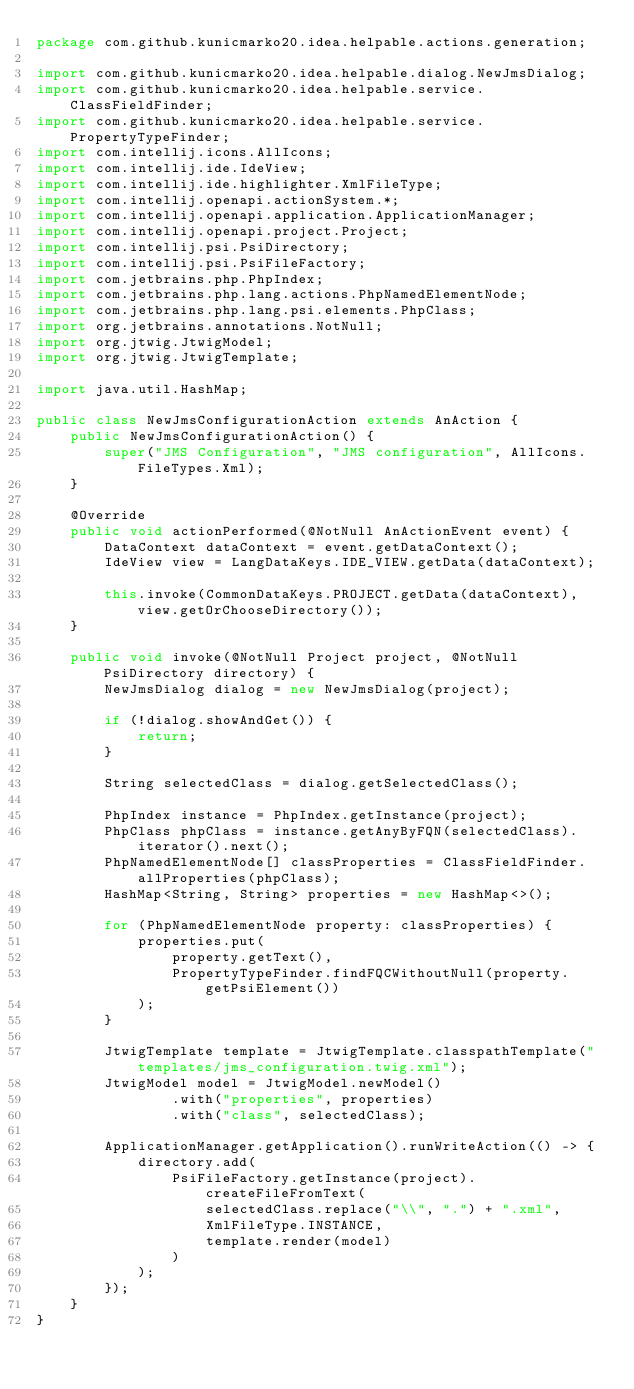<code> <loc_0><loc_0><loc_500><loc_500><_Java_>package com.github.kunicmarko20.idea.helpable.actions.generation;

import com.github.kunicmarko20.idea.helpable.dialog.NewJmsDialog;
import com.github.kunicmarko20.idea.helpable.service.ClassFieldFinder;
import com.github.kunicmarko20.idea.helpable.service.PropertyTypeFinder;
import com.intellij.icons.AllIcons;
import com.intellij.ide.IdeView;
import com.intellij.ide.highlighter.XmlFileType;
import com.intellij.openapi.actionSystem.*;
import com.intellij.openapi.application.ApplicationManager;
import com.intellij.openapi.project.Project;
import com.intellij.psi.PsiDirectory;
import com.intellij.psi.PsiFileFactory;
import com.jetbrains.php.PhpIndex;
import com.jetbrains.php.lang.actions.PhpNamedElementNode;
import com.jetbrains.php.lang.psi.elements.PhpClass;
import org.jetbrains.annotations.NotNull;
import org.jtwig.JtwigModel;
import org.jtwig.JtwigTemplate;

import java.util.HashMap;

public class NewJmsConfigurationAction extends AnAction {
    public NewJmsConfigurationAction() {
        super("JMS Configuration", "JMS configuration", AllIcons.FileTypes.Xml);
    }

    @Override
    public void actionPerformed(@NotNull AnActionEvent event) {
        DataContext dataContext = event.getDataContext();
        IdeView view = LangDataKeys.IDE_VIEW.getData(dataContext);

        this.invoke(CommonDataKeys.PROJECT.getData(dataContext), view.getOrChooseDirectory());
    }

    public void invoke(@NotNull Project project, @NotNull PsiDirectory directory) {
        NewJmsDialog dialog = new NewJmsDialog(project);

        if (!dialog.showAndGet()) {
            return;
        }

        String selectedClass = dialog.getSelectedClass();

        PhpIndex instance = PhpIndex.getInstance(project);
        PhpClass phpClass = instance.getAnyByFQN(selectedClass).iterator().next();
        PhpNamedElementNode[] classProperties = ClassFieldFinder.allProperties(phpClass);
        HashMap<String, String> properties = new HashMap<>();

        for (PhpNamedElementNode property: classProperties) {
            properties.put(
                property.getText(),
                PropertyTypeFinder.findFQCWithoutNull(property.getPsiElement())
            );
        }

        JtwigTemplate template = JtwigTemplate.classpathTemplate("templates/jms_configuration.twig.xml");
        JtwigModel model = JtwigModel.newModel()
                .with("properties", properties)
                .with("class", selectedClass);

        ApplicationManager.getApplication().runWriteAction(() -> {
            directory.add(
                PsiFileFactory.getInstance(project).createFileFromText(
                    selectedClass.replace("\\", ".") + ".xml",
                    XmlFileType.INSTANCE,
                    template.render(model)
                )
            );
        });
    }
}
</code> 